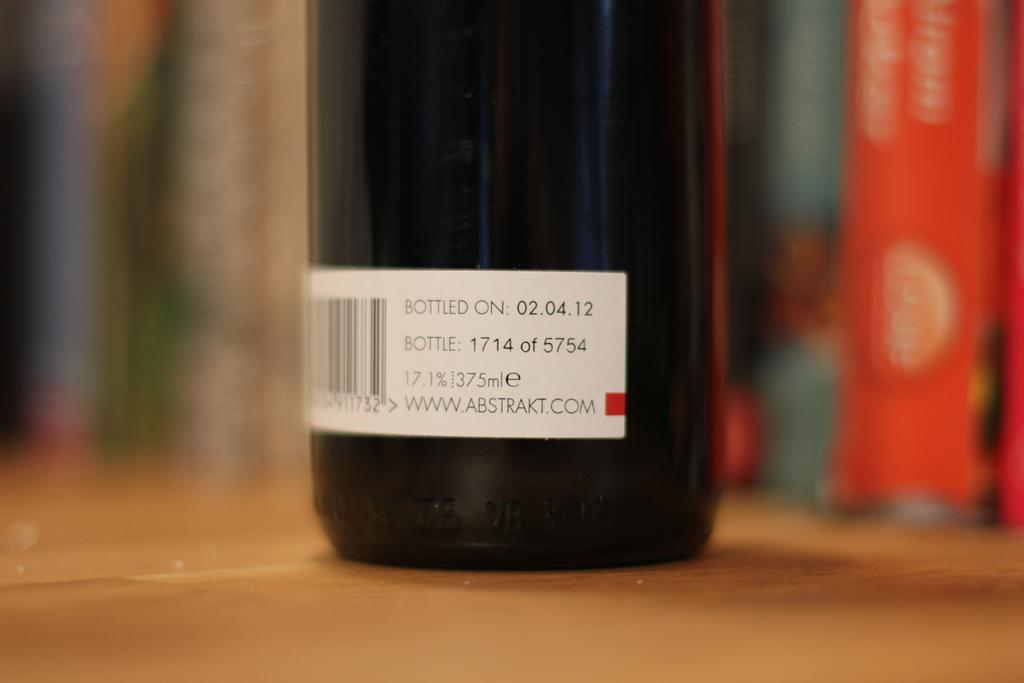<image>
Create a compact narrative representing the image presented. A bottle of wine from ABSTRAKT.COM placed on a right brown surface. 